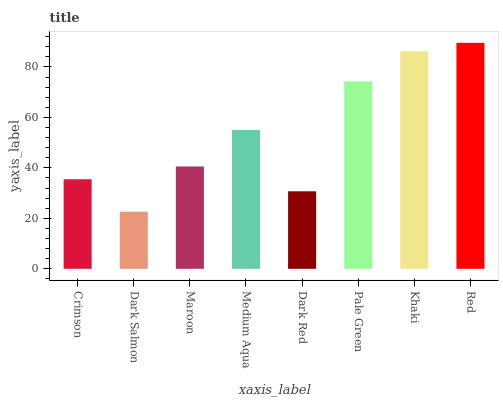Is Dark Salmon the minimum?
Answer yes or no. Yes. Is Red the maximum?
Answer yes or no. Yes. Is Maroon the minimum?
Answer yes or no. No. Is Maroon the maximum?
Answer yes or no. No. Is Maroon greater than Dark Salmon?
Answer yes or no. Yes. Is Dark Salmon less than Maroon?
Answer yes or no. Yes. Is Dark Salmon greater than Maroon?
Answer yes or no. No. Is Maroon less than Dark Salmon?
Answer yes or no. No. Is Medium Aqua the high median?
Answer yes or no. Yes. Is Maroon the low median?
Answer yes or no. Yes. Is Dark Red the high median?
Answer yes or no. No. Is Medium Aqua the low median?
Answer yes or no. No. 